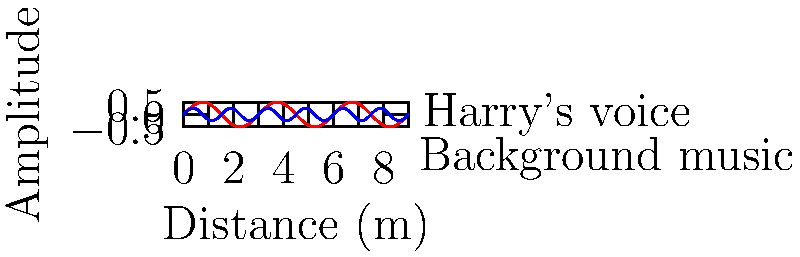At a Harry Styles concert, the sound waves from his microphone (red) and background music (blue) are represented in the graph. If the venue is 27 meters long, what is the wavelength of Harry's voice in meters? To find the wavelength of Harry's voice, we need to follow these steps:

1. Identify the wave represented by Harry's voice (red line).
2. Determine the period of this wave, which is the distance between two consecutive peaks or troughs.
3. Calculate the wavelength using the given information.

Step 1: The red line represents Harry's voice.

Step 2: Observing the red wave, we can see that one complete cycle (from peak to peak or trough to trough) occurs over 3 units on the x-axis.

Step 3: Calculate the wavelength:
- The graph shows 9 units on the x-axis, which represents the entire 27-meter length of the venue.
- So, 1 unit on the x-axis = 27/9 = 3 meters
- The period of the wave is 3 units, so the wavelength is:
  $$ \text{Wavelength} = 3 \text{ units} \times 3 \text{ meters/unit} = 9 \text{ meters} $$

Therefore, the wavelength of Harry's voice is 9 meters.
Answer: 9 meters 